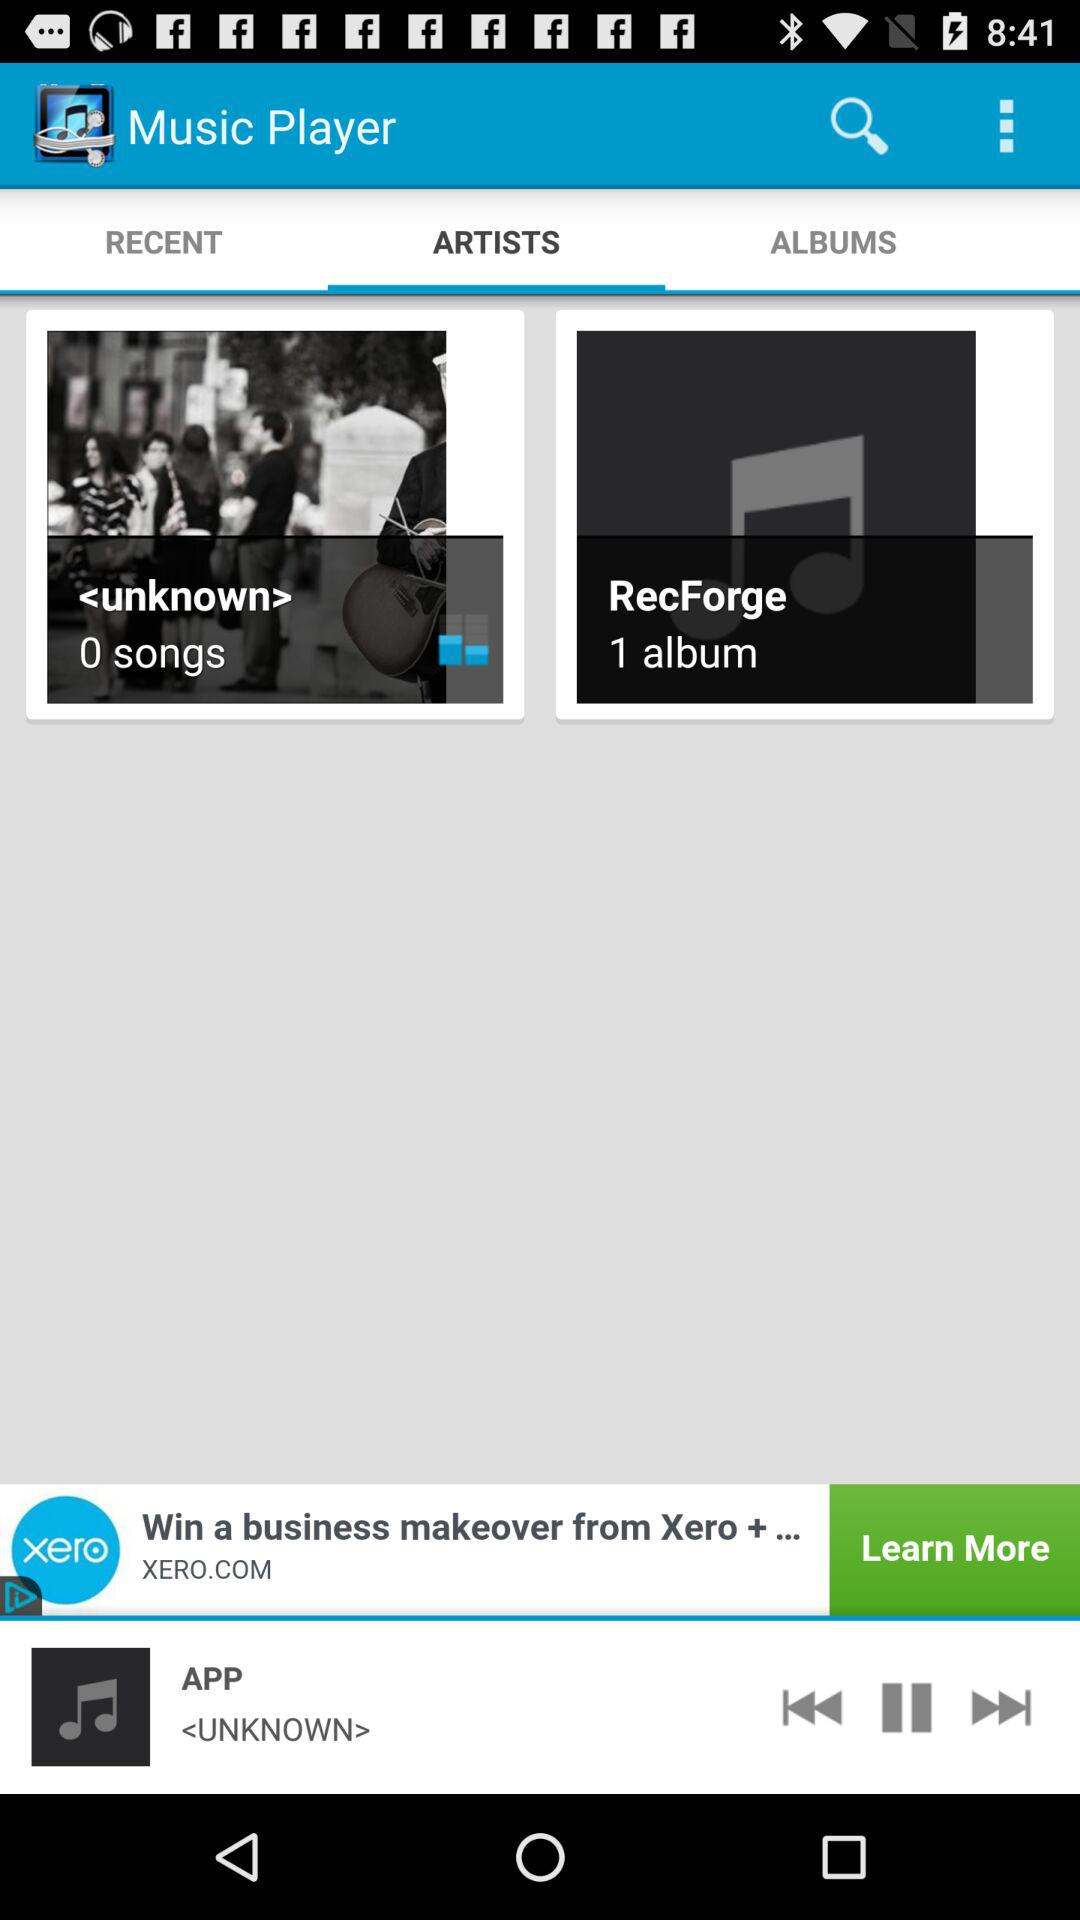How many songs are available in "<unknown>"? There are 0 songs available. 